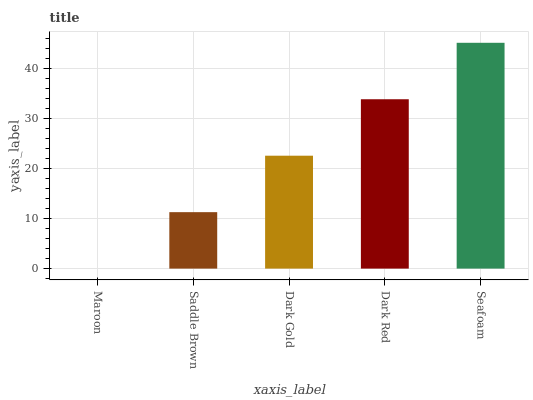Is Maroon the minimum?
Answer yes or no. Yes. Is Seafoam the maximum?
Answer yes or no. Yes. Is Saddle Brown the minimum?
Answer yes or no. No. Is Saddle Brown the maximum?
Answer yes or no. No. Is Saddle Brown greater than Maroon?
Answer yes or no. Yes. Is Maroon less than Saddle Brown?
Answer yes or no. Yes. Is Maroon greater than Saddle Brown?
Answer yes or no. No. Is Saddle Brown less than Maroon?
Answer yes or no. No. Is Dark Gold the high median?
Answer yes or no. Yes. Is Dark Gold the low median?
Answer yes or no. Yes. Is Maroon the high median?
Answer yes or no. No. Is Seafoam the low median?
Answer yes or no. No. 